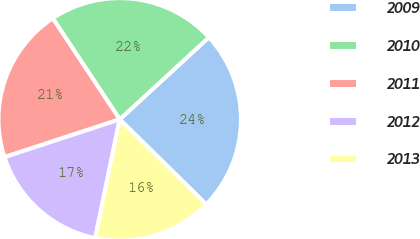Convert chart. <chart><loc_0><loc_0><loc_500><loc_500><pie_chart><fcel>2009<fcel>2010<fcel>2011<fcel>2012<fcel>2013<nl><fcel>24.2%<fcel>22.47%<fcel>20.73%<fcel>16.71%<fcel>15.88%<nl></chart> 